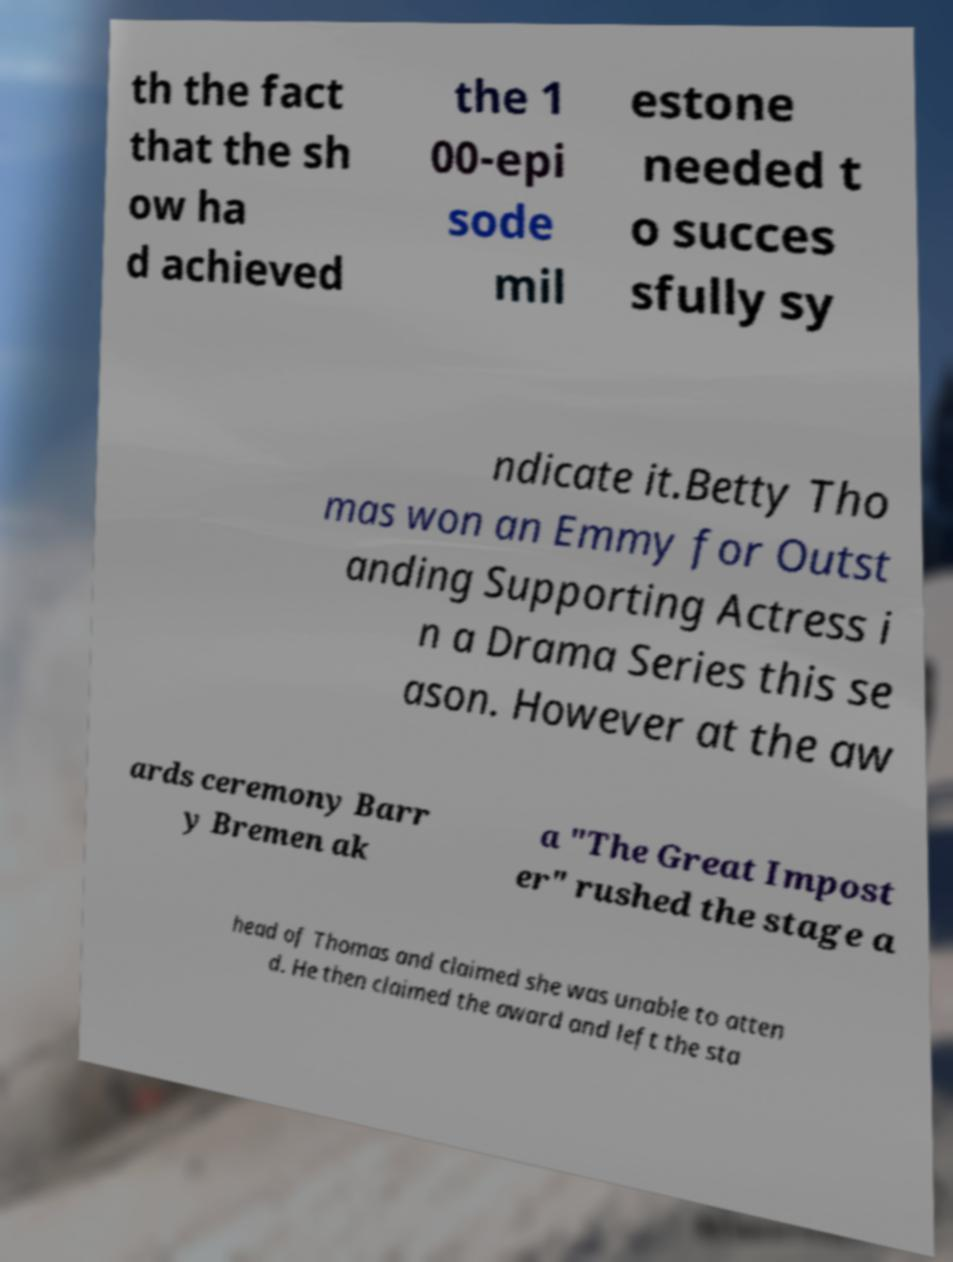Could you extract and type out the text from this image? th the fact that the sh ow ha d achieved the 1 00-epi sode mil estone needed t o succes sfully sy ndicate it.Betty Tho mas won an Emmy for Outst anding Supporting Actress i n a Drama Series this se ason. However at the aw ards ceremony Barr y Bremen ak a "The Great Impost er" rushed the stage a head of Thomas and claimed she was unable to atten d. He then claimed the award and left the sta 